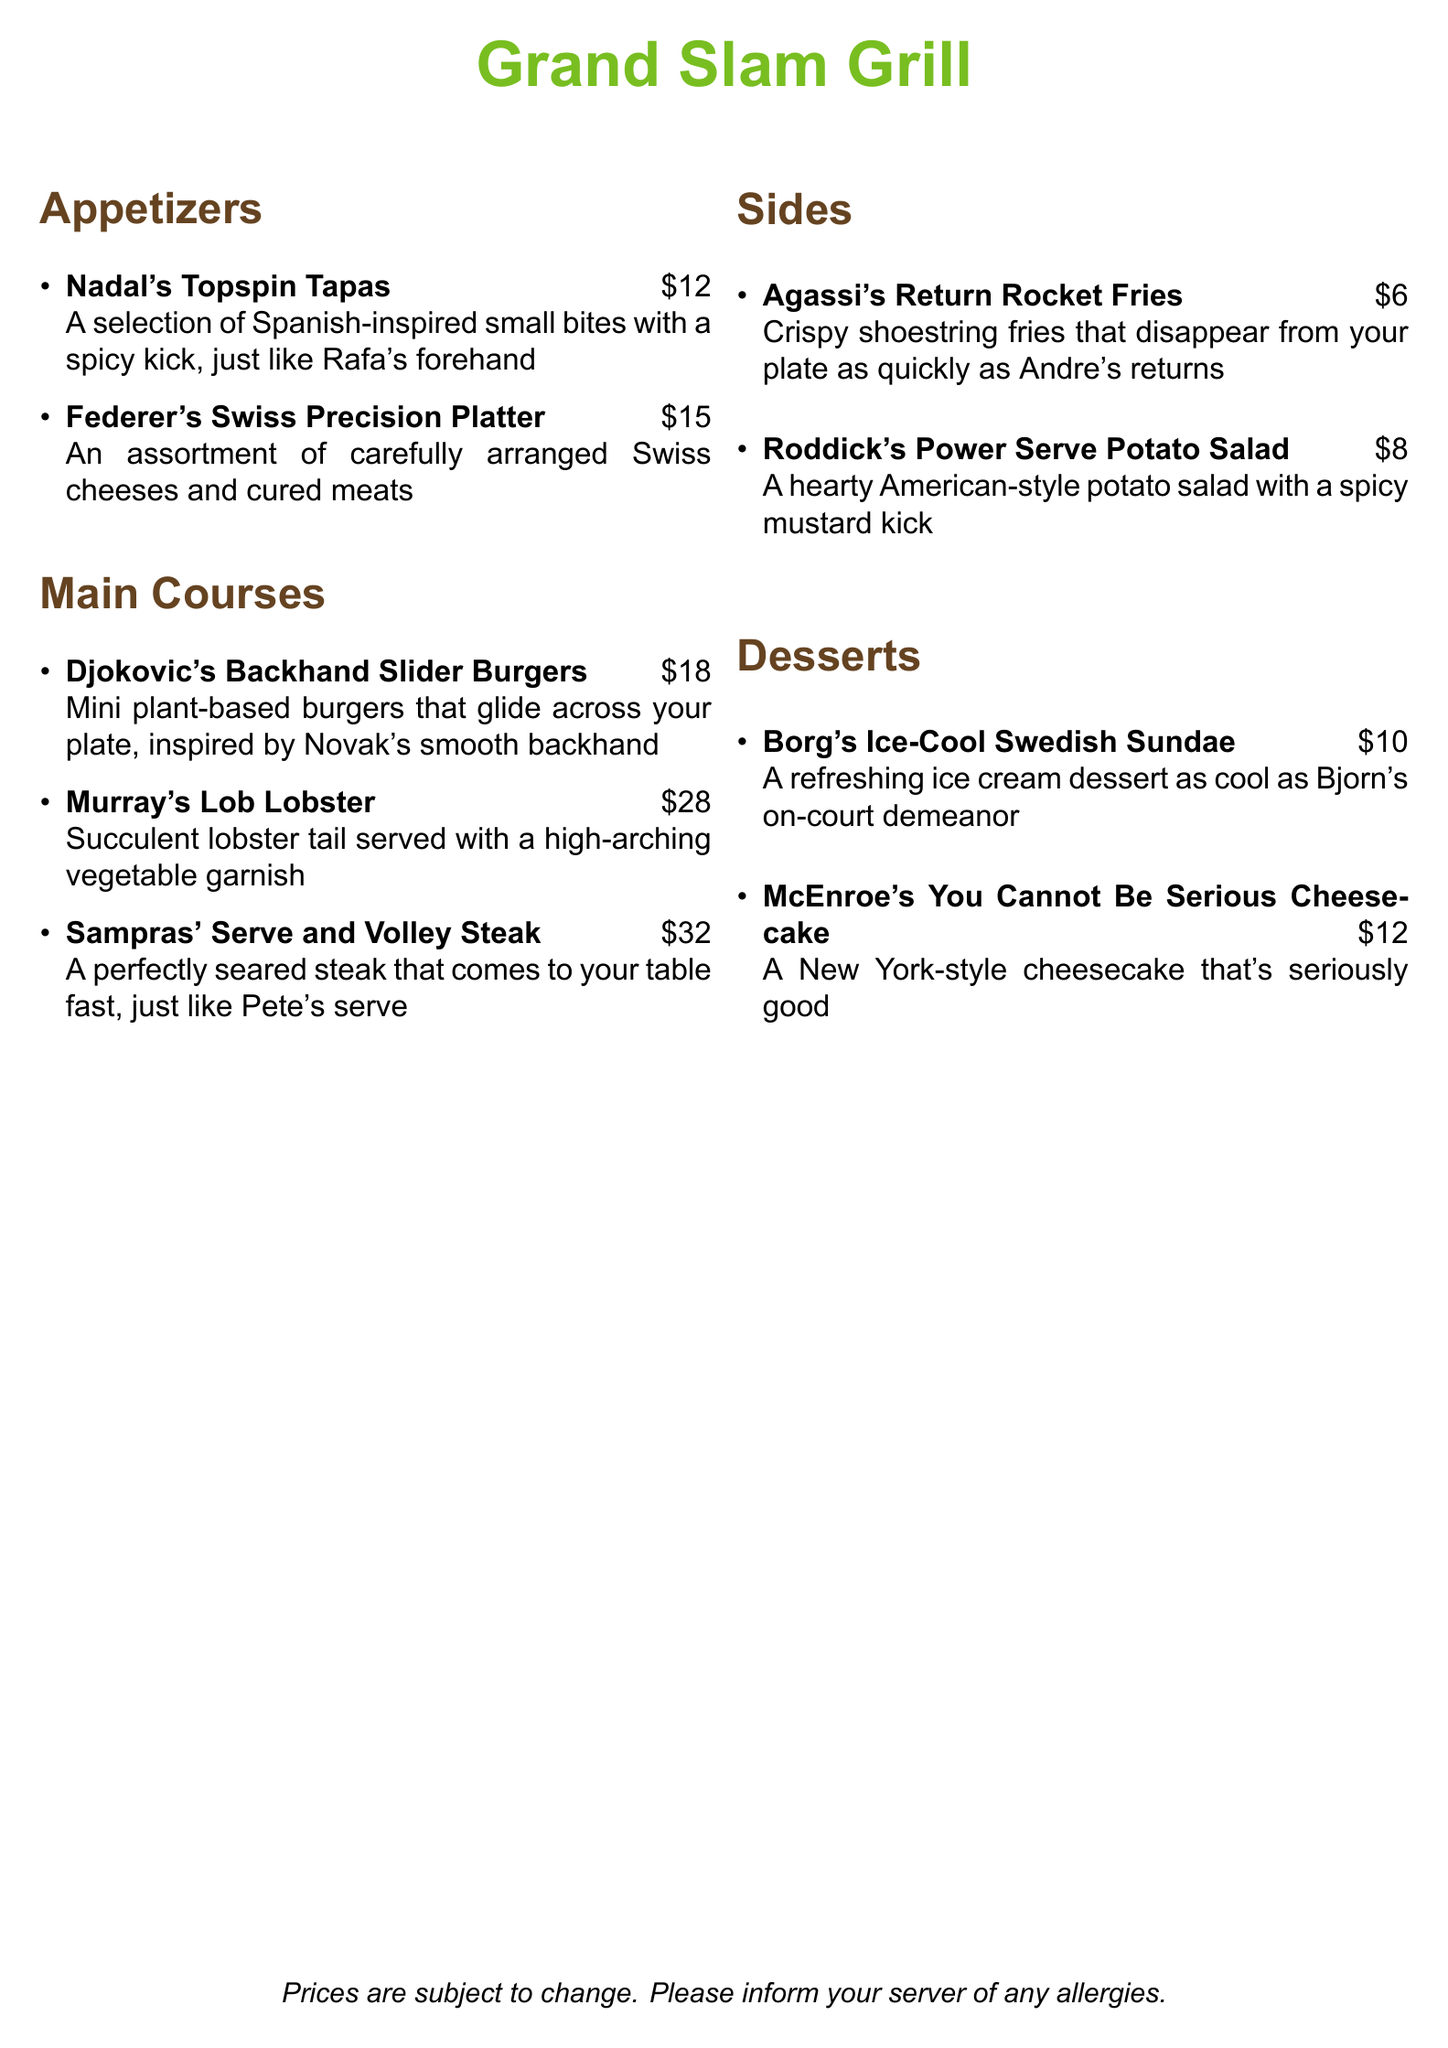What are the prices for the appetizers? The prices for the appetizers listed in the document are $12 for Nadal's Topspin Tapas and $15 for Federer's Swiss Precision Platter.
Answer: $12 and $15 What is the most expensive main course? The most expensive main course on the menu is Murray's Lob Lobster, which is priced at $28.
Answer: Murray's Lob Lobster How many side dishes are available? The document lists two side dishes: Agassi's Return Rocket Fries and Roddick's Power Serve Potato Salad.
Answer: Two Which dessert is inspired by a New York player? McEnroe's You Cannot Be Serious Cheesecake is inspired by a New York player, John McEnroe.
Answer: McEnroe's You Cannot Be Serious Cheesecake What type of salad is Roddick's dish? Roddick's dish is described as a potato salad, specifically a hearty American-style potato salad.
Answer: Potato salad What is the theme of the restaurant menu? The theme of the restaurant menu is inspired by famous men's tennis players, with dishes named after their signature moves.
Answer: Men's tennis players How much does Djokovic's dish cost? Djokovic's Backhand Slider Burgers are priced at $18 according to the menu.
Answer: $18 